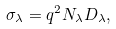<formula> <loc_0><loc_0><loc_500><loc_500>\sigma _ { \lambda } = q ^ { 2 } { N } _ { \lambda } D _ { \lambda } ,</formula> 